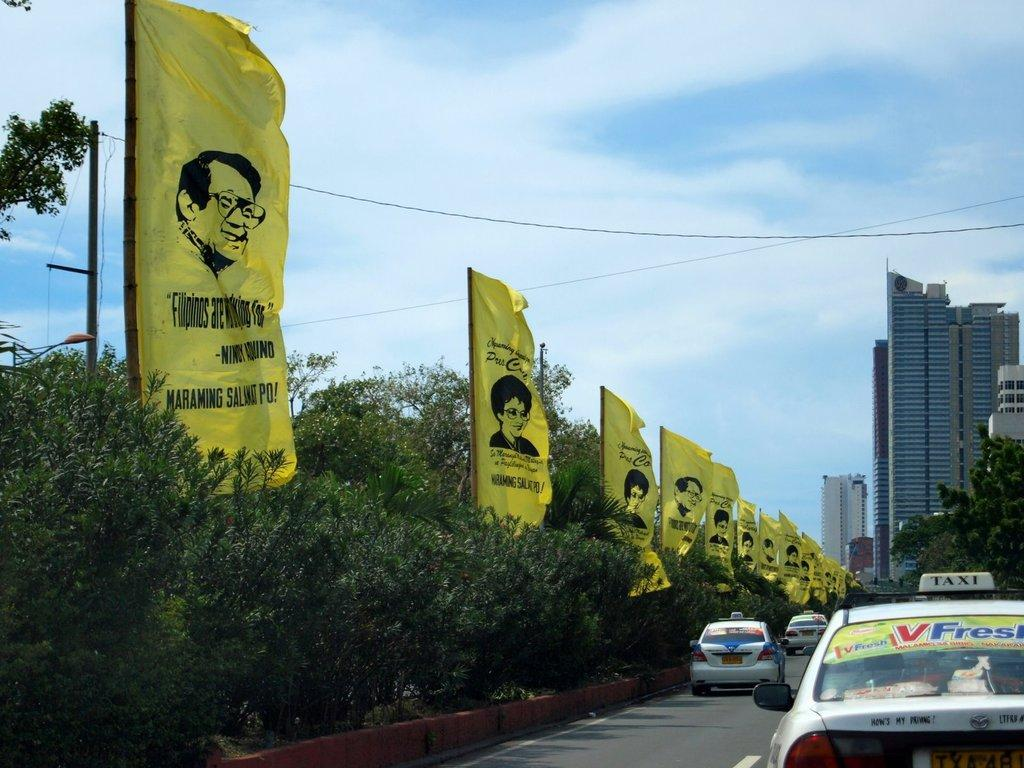<image>
Present a compact description of the photo's key features. some flags with one that says Filipinos on it 